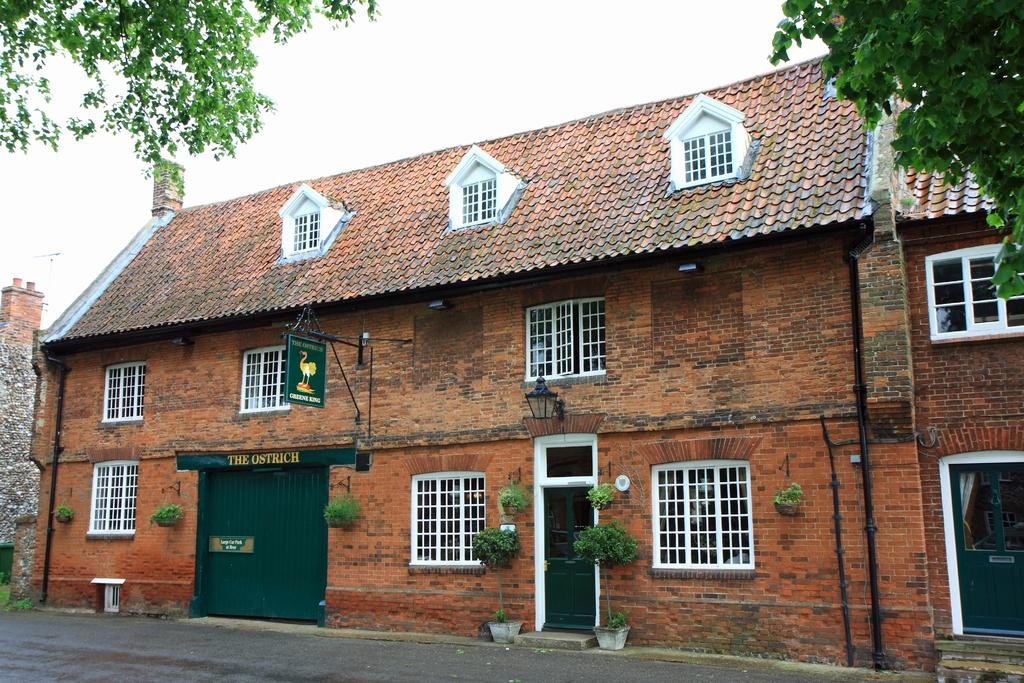What is located at the bottom of the image? There is a road at the bottom of the image. What structure is situated near the road? There is a building beside the road. What can be seen at the top of the image? The sky is visible at the top of the image. What type of vegetation is present in the image? Leaves of a tree are present in the image. What type of drink is being served by the animal in the image? There is no animal or drink present in the image. What is the texture of the leaves in the image? The provided facts do not mention the texture of the leaves, so it cannot be determined from the image. 